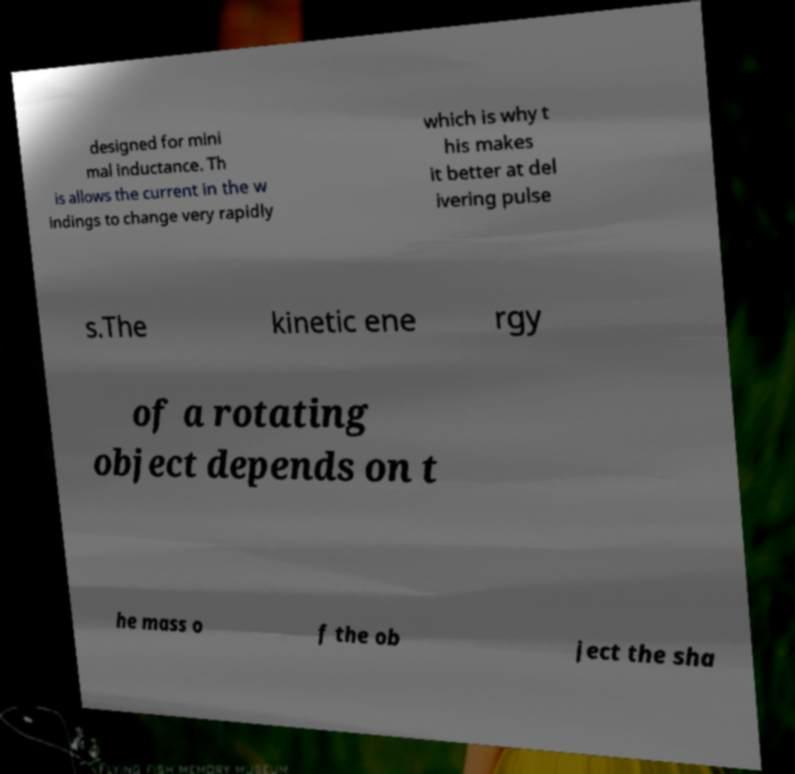For documentation purposes, I need the text within this image transcribed. Could you provide that? designed for mini mal inductance. Th is allows the current in the w indings to change very rapidly which is why t his makes it better at del ivering pulse s.The kinetic ene rgy of a rotating object depends on t he mass o f the ob ject the sha 